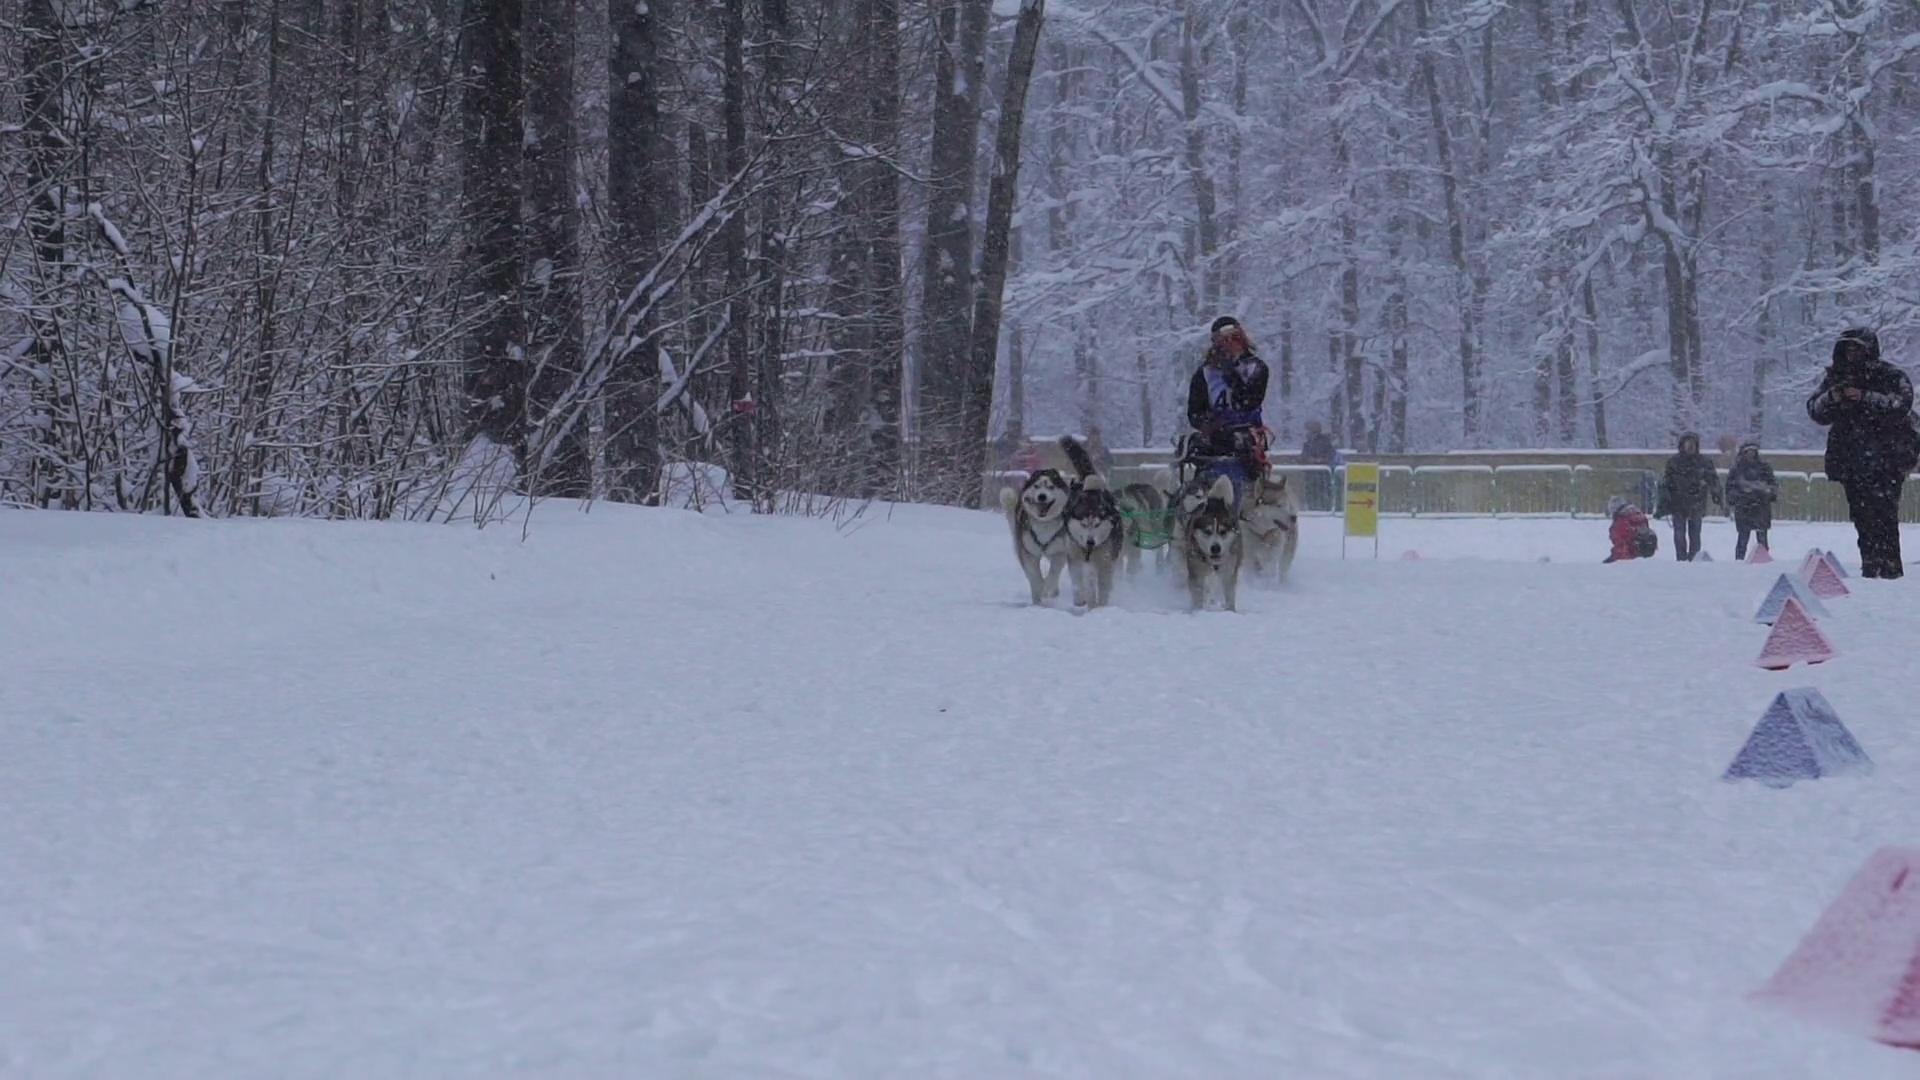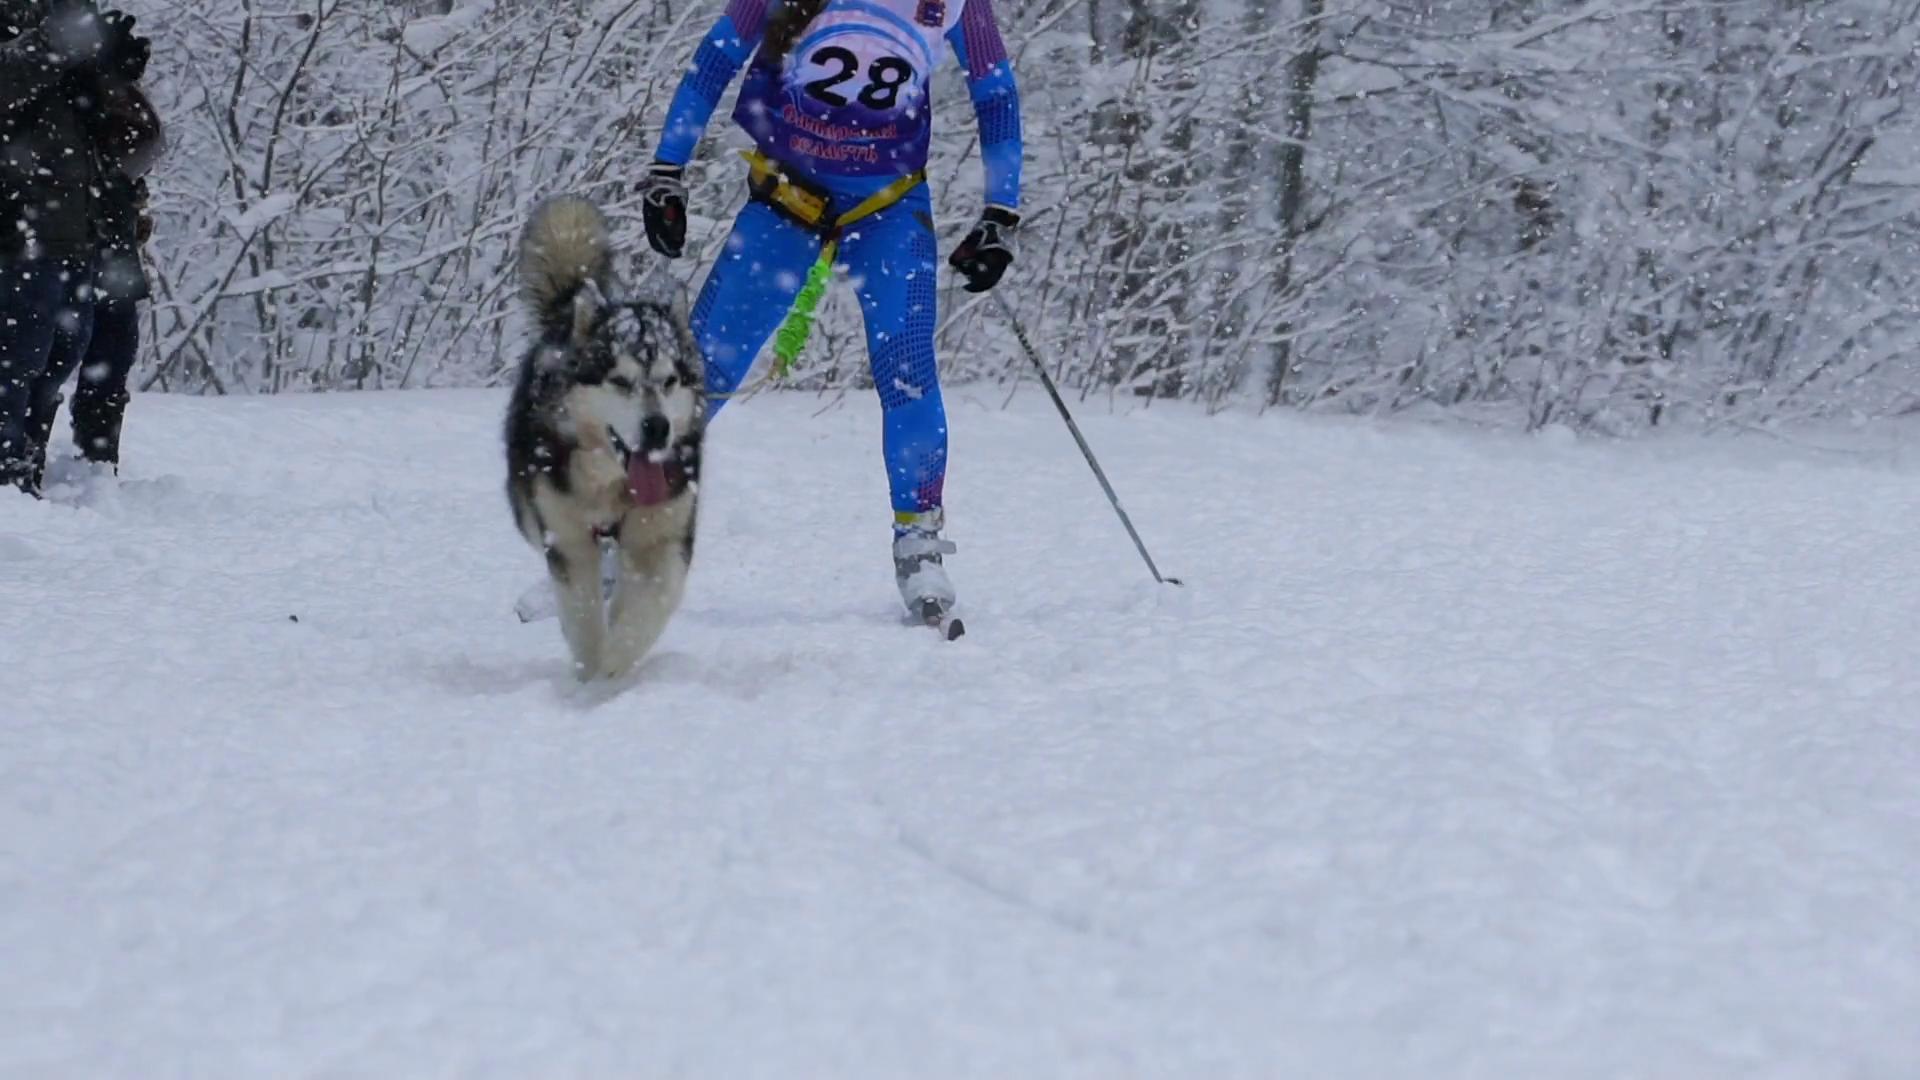The first image is the image on the left, the second image is the image on the right. For the images displayed, is the sentence "One image shows a team of dogs heading away from the camera toward a background of mountains." factually correct? Answer yes or no. No. 